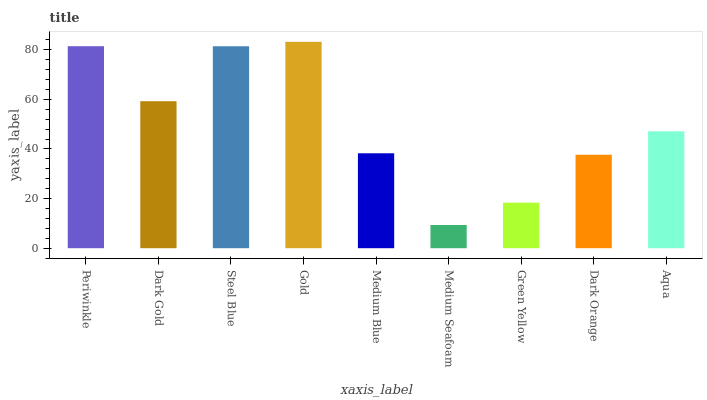Is Medium Seafoam the minimum?
Answer yes or no. Yes. Is Gold the maximum?
Answer yes or no. Yes. Is Dark Gold the minimum?
Answer yes or no. No. Is Dark Gold the maximum?
Answer yes or no. No. Is Periwinkle greater than Dark Gold?
Answer yes or no. Yes. Is Dark Gold less than Periwinkle?
Answer yes or no. Yes. Is Dark Gold greater than Periwinkle?
Answer yes or no. No. Is Periwinkle less than Dark Gold?
Answer yes or no. No. Is Aqua the high median?
Answer yes or no. Yes. Is Aqua the low median?
Answer yes or no. Yes. Is Green Yellow the high median?
Answer yes or no. No. Is Gold the low median?
Answer yes or no. No. 